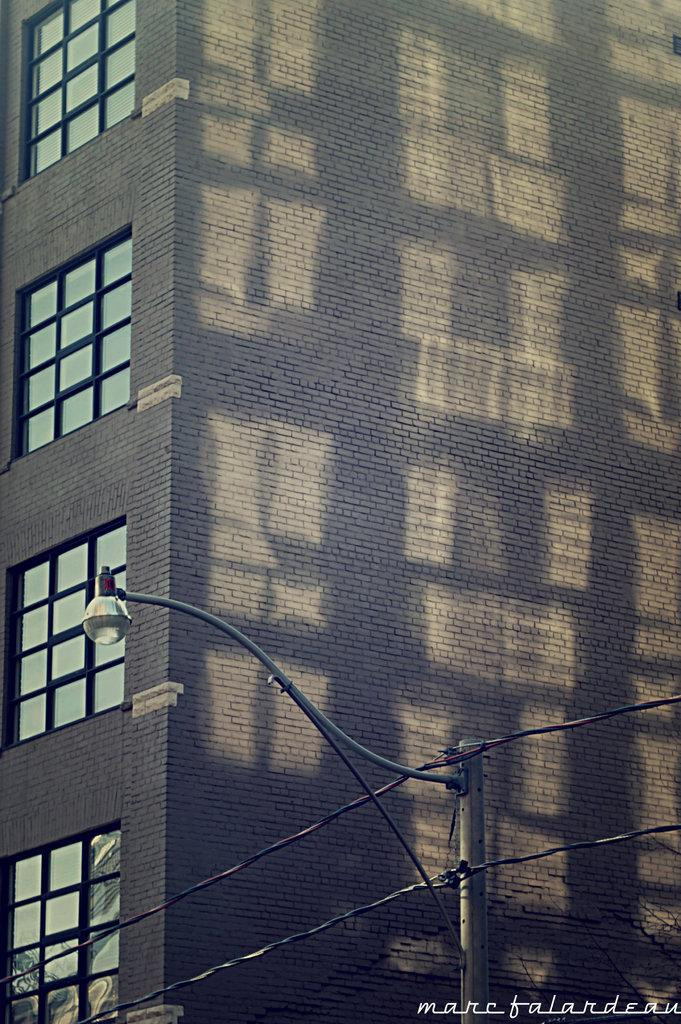What type of structure is visible in the image? There is a building in the image. What feature can be seen on the left side of the building? The building has glass windows on the left side. What is located at the bottom of the building? There is a pole at the bottom of the building. What is attached to the pole? A light is attached to the pole. Who is the creator of the drain visible in the image? There is no drain present in the image, so it is not possible to determine the creator. 